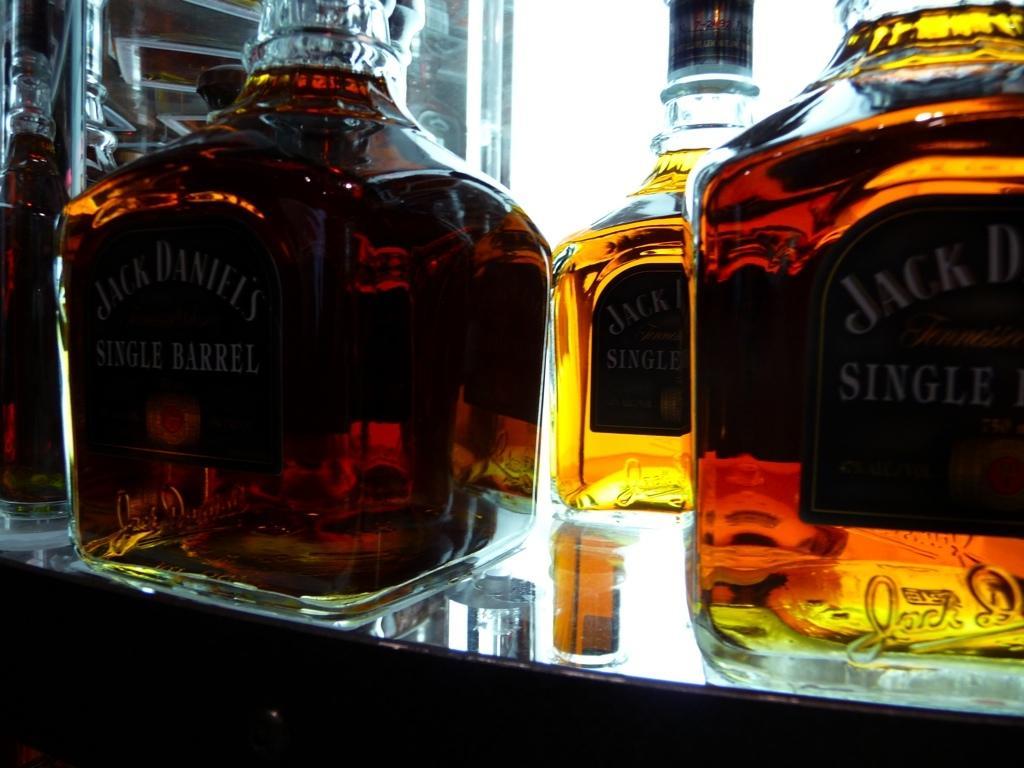Can you describe this image briefly? In this image I can see few glass bottles on the table. 